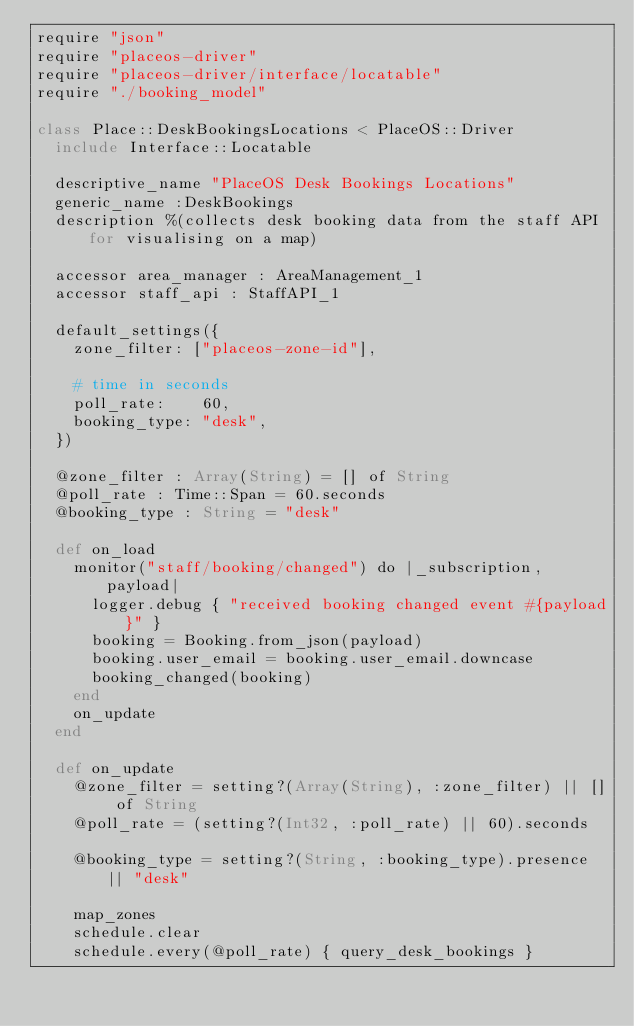<code> <loc_0><loc_0><loc_500><loc_500><_Crystal_>require "json"
require "placeos-driver"
require "placeos-driver/interface/locatable"
require "./booking_model"

class Place::DeskBookingsLocations < PlaceOS::Driver
  include Interface::Locatable

  descriptive_name "PlaceOS Desk Bookings Locations"
  generic_name :DeskBookings
  description %(collects desk booking data from the staff API for visualising on a map)

  accessor area_manager : AreaManagement_1
  accessor staff_api : StaffAPI_1

  default_settings({
    zone_filter: ["placeos-zone-id"],

    # time in seconds
    poll_rate:    60,
    booking_type: "desk",
  })

  @zone_filter : Array(String) = [] of String
  @poll_rate : Time::Span = 60.seconds
  @booking_type : String = "desk"

  def on_load
    monitor("staff/booking/changed") do |_subscription, payload|
      logger.debug { "received booking changed event #{payload}" }
      booking = Booking.from_json(payload)
      booking.user_email = booking.user_email.downcase
      booking_changed(booking)
    end
    on_update
  end

  def on_update
    @zone_filter = setting?(Array(String), :zone_filter) || [] of String
    @poll_rate = (setting?(Int32, :poll_rate) || 60).seconds

    @booking_type = setting?(String, :booking_type).presence || "desk"

    map_zones
    schedule.clear
    schedule.every(@poll_rate) { query_desk_bookings }</code> 